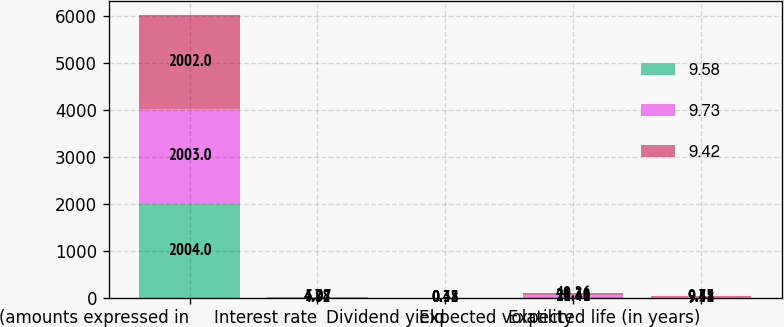Convert chart. <chart><loc_0><loc_0><loc_500><loc_500><stacked_bar_chart><ecel><fcel>(amounts expressed in<fcel>Interest rate<fcel>Dividend yield<fcel>Expected volatility<fcel>Expected life (in years)<nl><fcel>9.58<fcel>2004<fcel>4.82<fcel>0.32<fcel>21.41<fcel>9.58<nl><fcel>9.73<fcel>2003<fcel>5.07<fcel>0.38<fcel>28.38<fcel>9.42<nl><fcel>9.42<fcel>2002<fcel>4.78<fcel>0.43<fcel>40.26<fcel>9.73<nl></chart> 